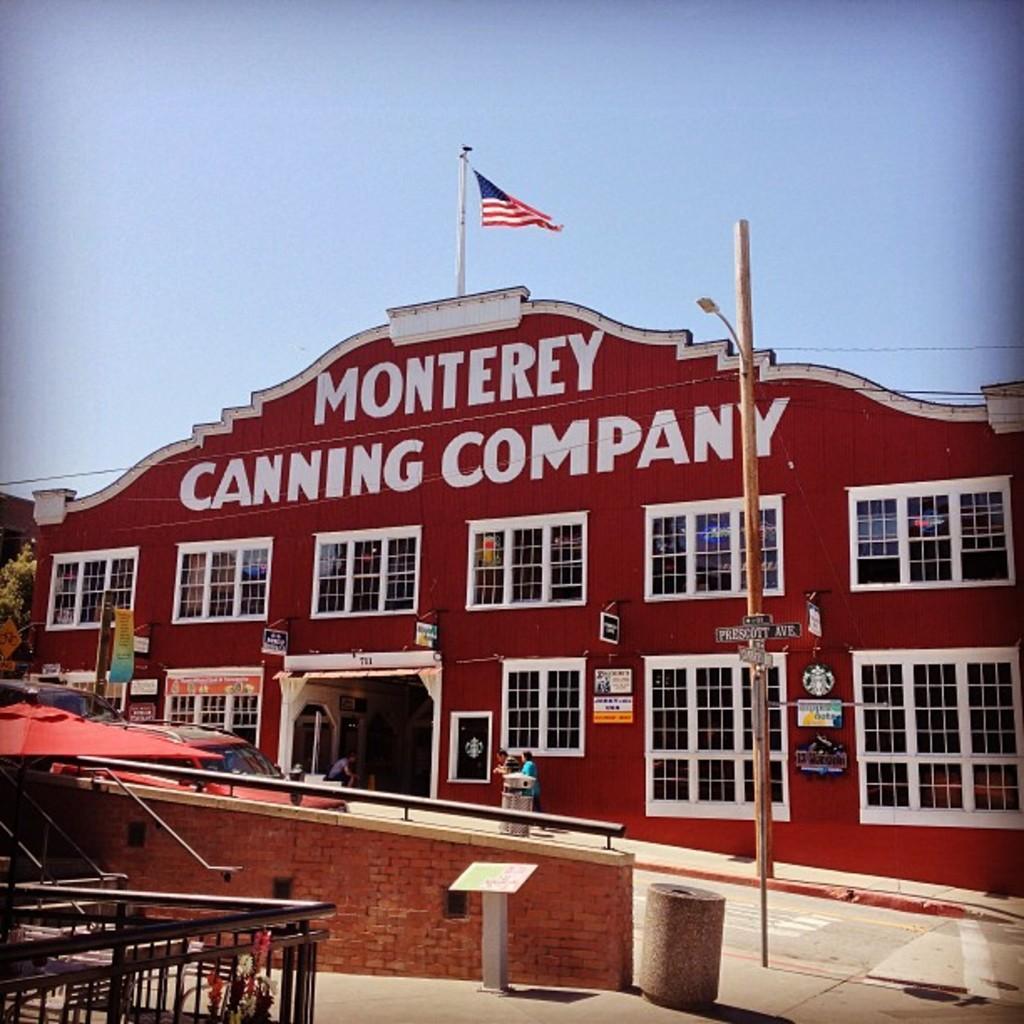Describe this image in one or two sentences. In this picture we can see a building and a few windows on it. There is a flag on this building. We can see a bin on the path. There is a vehicle on the road. 